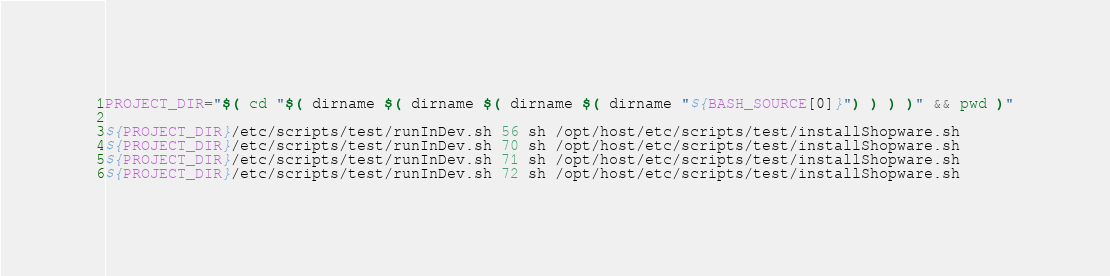Convert code to text. <code><loc_0><loc_0><loc_500><loc_500><_Bash_>PROJECT_DIR="$( cd "$( dirname $( dirname $( dirname $( dirname "${BASH_SOURCE[0]}") ) ) )" && pwd )"

${PROJECT_DIR}/etc/scripts/test/runInDev.sh 56 sh /opt/host/etc/scripts/test/installShopware.sh
${PROJECT_DIR}/etc/scripts/test/runInDev.sh 70 sh /opt/host/etc/scripts/test/installShopware.sh
${PROJECT_DIR}/etc/scripts/test/runInDev.sh 71 sh /opt/host/etc/scripts/test/installShopware.sh
${PROJECT_DIR}/etc/scripts/test/runInDev.sh 72 sh /opt/host/etc/scripts/test/installShopware.sh

</code> 